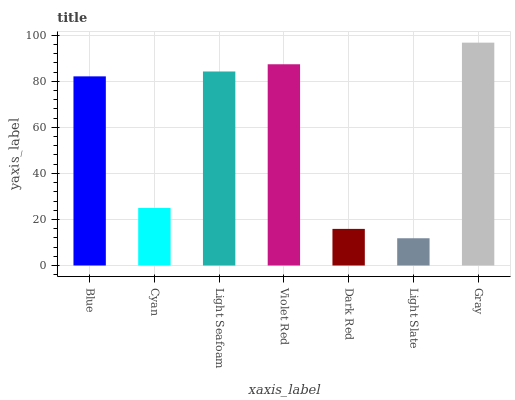Is Light Slate the minimum?
Answer yes or no. Yes. Is Gray the maximum?
Answer yes or no. Yes. Is Cyan the minimum?
Answer yes or no. No. Is Cyan the maximum?
Answer yes or no. No. Is Blue greater than Cyan?
Answer yes or no. Yes. Is Cyan less than Blue?
Answer yes or no. Yes. Is Cyan greater than Blue?
Answer yes or no. No. Is Blue less than Cyan?
Answer yes or no. No. Is Blue the high median?
Answer yes or no. Yes. Is Blue the low median?
Answer yes or no. Yes. Is Dark Red the high median?
Answer yes or no. No. Is Gray the low median?
Answer yes or no. No. 